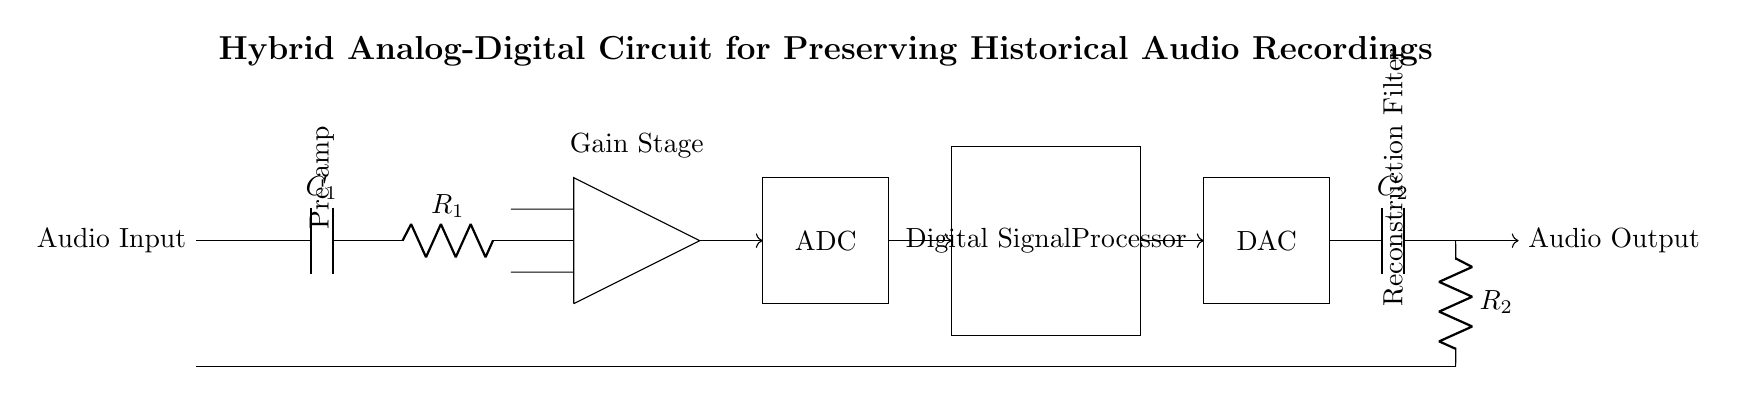What is the function of component C1? C1 is a capacitor that is used for coupling the audio signal, allowing AC signals to pass while blocking DC.
Answer: Coupling capacitor What is the purpose of the operational amplifier in the circuit? The operational amplifier amplifies the audio signal to a desired level before conversion. It serves as the gain stage, enhancing the signal for further processing.
Answer: Signal amplification How many main functional blocks are in this circuit? The circuit consists of four main functional blocks: the pre-amplifier, ADC, digital signal processor (DSP), and DAC.
Answer: Four What type of filtering is performed by C2 and R2? C2 and R2 form a low-pass filter, which smooths out high-frequency components from the audio signal during the reconstruction phase.
Answer: Low-pass filtering What is the final output of this hybrid circuit? The final output is the preserved audio signal, which is routed to audio output after digital processing.
Answer: Preserved audio signal Which component converts the analog signal to digital? The ADC (Analog to Digital Converter) converts the analog audio signal to a digital format suitable for the digital signal processor.
Answer: ADC What is indicated by the arrows in the circuit diagram? The arrows indicate the direction of signal flow within the circuit, illustrating how the audio signal moves through each component.
Answer: Signal flow direction 